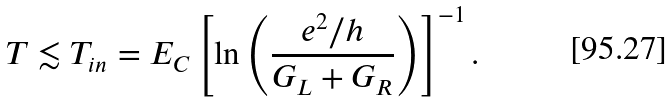<formula> <loc_0><loc_0><loc_500><loc_500>T \lesssim T _ { i n } = E _ { C } \left [ \ln \left ( \frac { e ^ { 2 } / h } { G _ { L } + G _ { R } } \right ) \right ] ^ { - 1 } .</formula> 